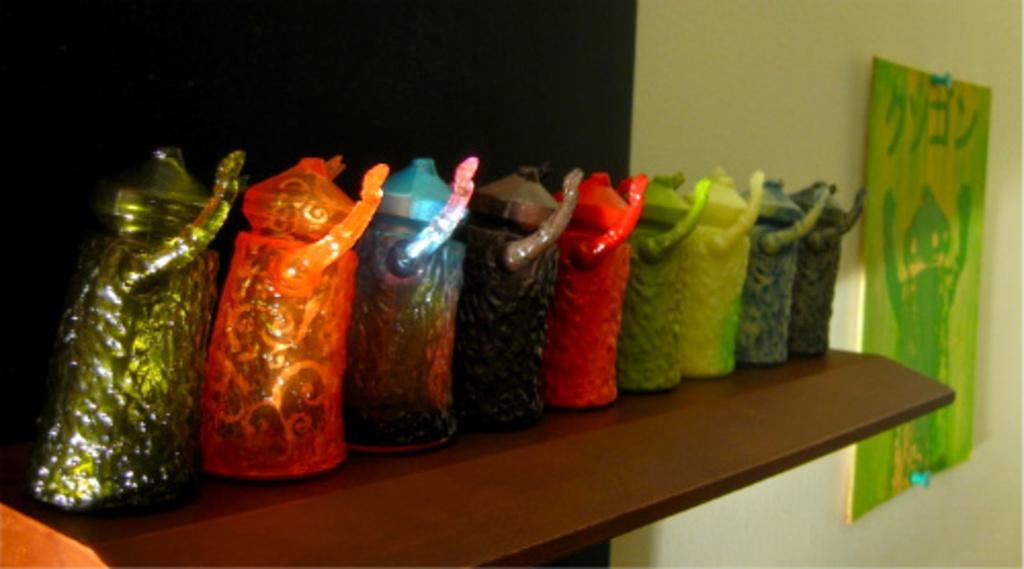Describe this image in one or two sentences. In this image I can see different colored decorative items on the rack. The rack is in brown color. On the wall the frame is attached to it. The wall is in black color. 